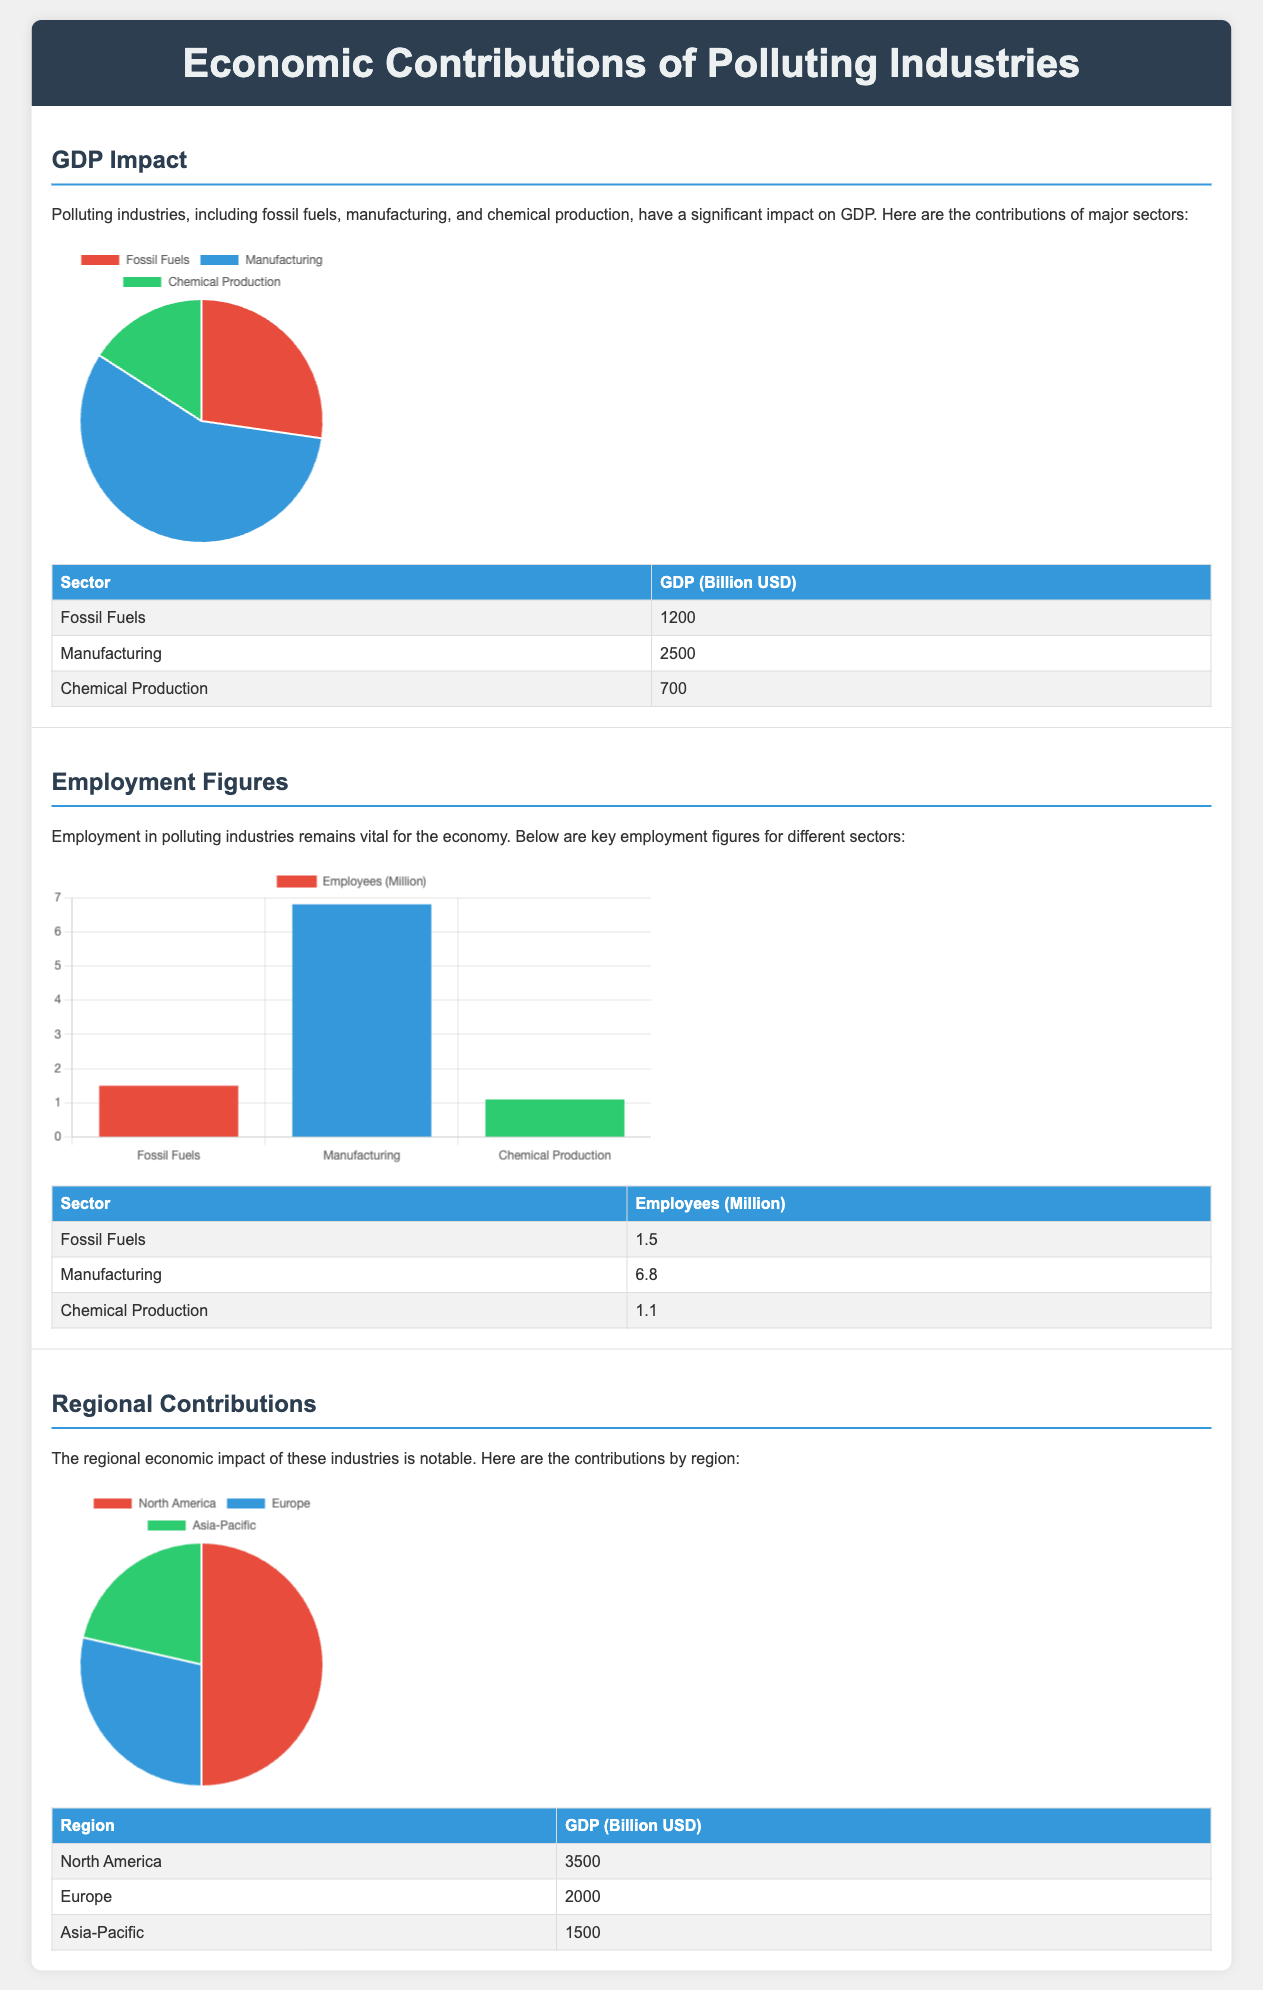What is the GDP contribution of the manufacturing sector? The manufacturing sector contributes 2500 billion USD to GDP according to the data presented in the document.
Answer: 2500 billion USD How many employees are there in the fossil fuels sector? The document states that there are 1.5 million employees in the fossil fuels sector.
Answer: 1.5 million What is the total GDP contribution of North America? The GDP contribution of North America is 3500 billion USD, as indicated in the regional contributions section.
Answer: 3500 billion USD Which sector has the highest employment figures? According to the employment figures presented, the manufacturing sector has the highest employment figures at 6.8 million employees.
Answer: Manufacturing What is the total GDP from chemical production? The total GDP contribution from chemical production is shown as 700 billion USD in the GDP impact section.
Answer: 700 billion USD What percentage of GDP does the fossil fuels sector represent compared to manufacturing? The fossil fuels sector contributes 1200 billion USD while manufacturing contributes 2500 billion USD, thus requiring a comparison for reasoning.
Answer: 48% (1200 billion USD / 2500 billion USD * 100) How many regions are represented in this infographic? The infographic includes three regions for economic contributions: North America, Europe, and Asia-Pacific.
Answer: Three Which region has the lowest GDP contribution? Among the regions listed, Asia-Pacific has the lowest GDP contribution of 1500 billion USD according to the regional contributions data.
Answer: Asia-Pacific 